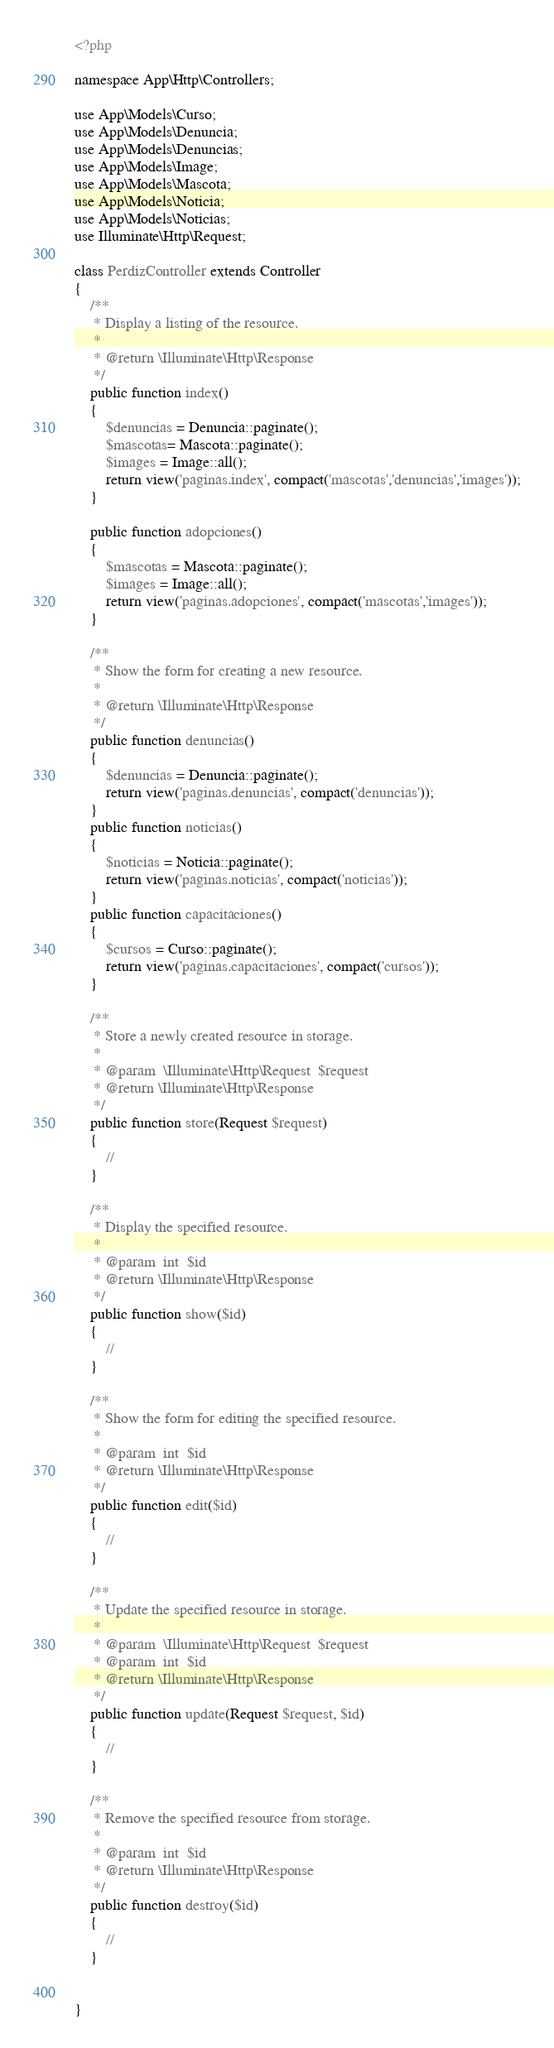<code> <loc_0><loc_0><loc_500><loc_500><_PHP_><?php

namespace App\Http\Controllers;

use App\Models\Curso;
use App\Models\Denuncia;
use App\Models\Denuncias;
use App\Models\Image;
use App\Models\Mascota;
use App\Models\Noticia;
use App\Models\Noticias;
use Illuminate\Http\Request;

class PerdizController extends Controller
{
    /**
     * Display a listing of the resource.
     *
     * @return \Illuminate\Http\Response
     */
    public function index()
    {   
        $denuncias = Denuncia::paginate();
        $mascotas= Mascota::paginate();
        $images = Image::all();
        return view('paginas.index', compact('mascotas','denuncias','images'));
    }

    public function adopciones()
    {
        $mascotas = Mascota::paginate();
        $images = Image::all();
        return view('paginas.adopciones', compact('mascotas','images'));
    }

    /**
     * Show the form for creating a new resource.
     *
     * @return \Illuminate\Http\Response
     */
    public function denuncias()
    {
        $denuncias = Denuncia::paginate();
        return view('paginas.denuncias', compact('denuncias'));
    }
    public function noticias()
    {
        $noticias = Noticia::paginate();
        return view('paginas.noticias', compact('noticias'));
    }
    public function capacitaciones()
    {
        $cursos = Curso::paginate();
        return view('paginas.capacitaciones', compact('cursos'));
    }

    /**
     * Store a newly created resource in storage.
     *
     * @param  \Illuminate\Http\Request  $request
     * @return \Illuminate\Http\Response
     */
    public function store(Request $request)
    {
        //
    }

    /**
     * Display the specified resource.
     *
     * @param  int  $id
     * @return \Illuminate\Http\Response
     */
    public function show($id)
    {
        //
    }

    /**
     * Show the form for editing the specified resource.
     *
     * @param  int  $id
     * @return \Illuminate\Http\Response
     */
    public function edit($id)
    {
        //
    }

    /**
     * Update the specified resource in storage.
     *
     * @param  \Illuminate\Http\Request  $request
     * @param  int  $id
     * @return \Illuminate\Http\Response
     */
    public function update(Request $request, $id)
    {
        //
    }

    /**
     * Remove the specified resource from storage.
     *
     * @param  int  $id
     * @return \Illuminate\Http\Response
     */
    public function destroy($id)
    {
        //
    }

    
}
</code> 